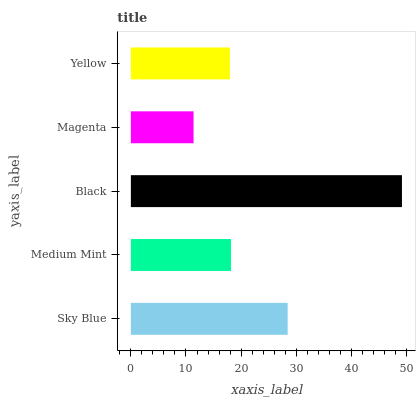Is Magenta the minimum?
Answer yes or no. Yes. Is Black the maximum?
Answer yes or no. Yes. Is Medium Mint the minimum?
Answer yes or no. No. Is Medium Mint the maximum?
Answer yes or no. No. Is Sky Blue greater than Medium Mint?
Answer yes or no. Yes. Is Medium Mint less than Sky Blue?
Answer yes or no. Yes. Is Medium Mint greater than Sky Blue?
Answer yes or no. No. Is Sky Blue less than Medium Mint?
Answer yes or no. No. Is Medium Mint the high median?
Answer yes or no. Yes. Is Medium Mint the low median?
Answer yes or no. Yes. Is Magenta the high median?
Answer yes or no. No. Is Yellow the low median?
Answer yes or no. No. 